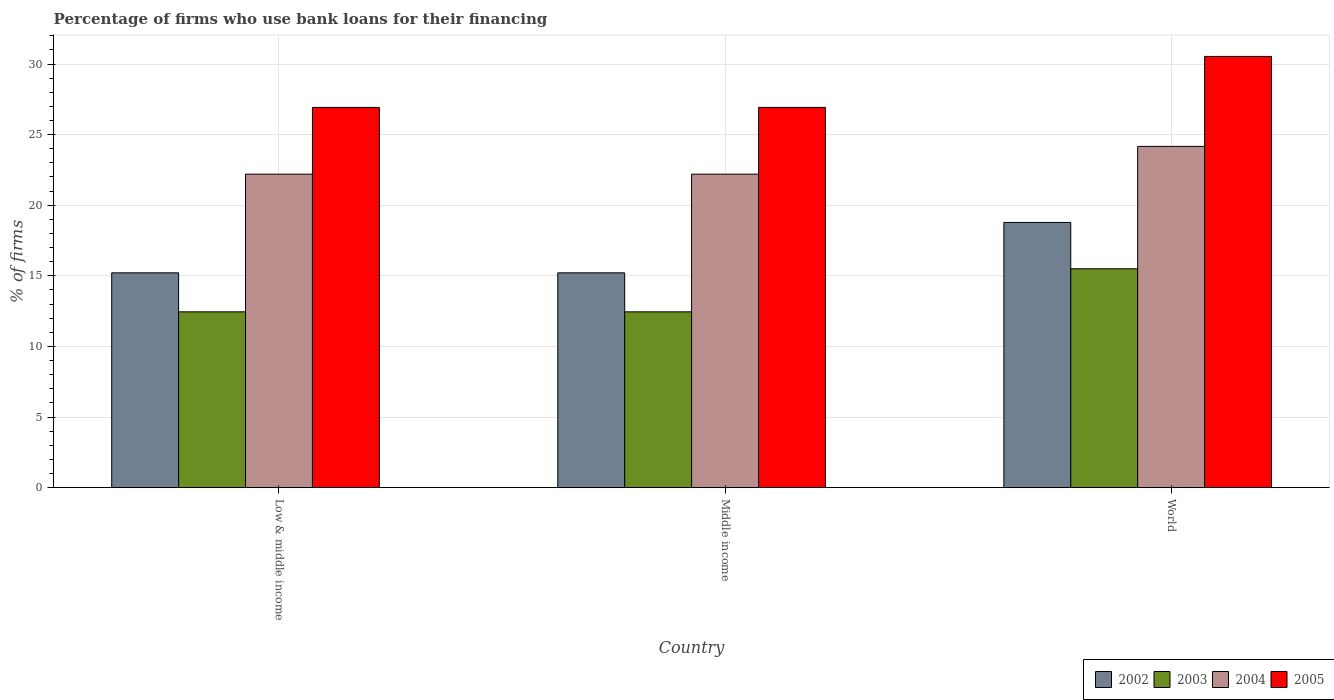Are the number of bars per tick equal to the number of legend labels?
Make the answer very short. Yes. How many bars are there on the 2nd tick from the left?
Your response must be concise. 4. How many bars are there on the 2nd tick from the right?
Provide a short and direct response. 4. What is the label of the 3rd group of bars from the left?
Ensure brevity in your answer.  World. What is the percentage of firms who use bank loans for their financing in 2005 in World?
Offer a very short reply. 30.54. Across all countries, what is the minimum percentage of firms who use bank loans for their financing in 2003?
Your response must be concise. 12.45. In which country was the percentage of firms who use bank loans for their financing in 2002 maximum?
Your answer should be very brief. World. What is the total percentage of firms who use bank loans for their financing in 2003 in the graph?
Provide a succinct answer. 40.4. What is the difference between the percentage of firms who use bank loans for their financing in 2004 in Low & middle income and that in World?
Your answer should be very brief. -1.97. What is the difference between the percentage of firms who use bank loans for their financing in 2003 in Middle income and the percentage of firms who use bank loans for their financing in 2005 in World?
Provide a short and direct response. -18.09. What is the average percentage of firms who use bank loans for their financing in 2003 per country?
Give a very brief answer. 13.47. What is the difference between the percentage of firms who use bank loans for their financing of/in 2004 and percentage of firms who use bank loans for their financing of/in 2005 in Low & middle income?
Keep it short and to the point. -4.73. In how many countries, is the percentage of firms who use bank loans for their financing in 2005 greater than 31 %?
Give a very brief answer. 0. What is the ratio of the percentage of firms who use bank loans for their financing in 2005 in Low & middle income to that in Middle income?
Give a very brief answer. 1. What is the difference between the highest and the second highest percentage of firms who use bank loans for their financing in 2003?
Your answer should be compact. -3.05. What is the difference between the highest and the lowest percentage of firms who use bank loans for their financing in 2003?
Your answer should be very brief. 3.05. In how many countries, is the percentage of firms who use bank loans for their financing in 2002 greater than the average percentage of firms who use bank loans for their financing in 2002 taken over all countries?
Offer a very short reply. 1. Is the sum of the percentage of firms who use bank loans for their financing in 2005 in Low & middle income and Middle income greater than the maximum percentage of firms who use bank loans for their financing in 2003 across all countries?
Offer a terse response. Yes. Is it the case that in every country, the sum of the percentage of firms who use bank loans for their financing in 2005 and percentage of firms who use bank loans for their financing in 2002 is greater than the sum of percentage of firms who use bank loans for their financing in 2003 and percentage of firms who use bank loans for their financing in 2004?
Offer a very short reply. No. What does the 3rd bar from the right in World represents?
Provide a succinct answer. 2003. Is it the case that in every country, the sum of the percentage of firms who use bank loans for their financing in 2002 and percentage of firms who use bank loans for their financing in 2003 is greater than the percentage of firms who use bank loans for their financing in 2005?
Offer a terse response. Yes. How many countries are there in the graph?
Ensure brevity in your answer.  3. What is the difference between two consecutive major ticks on the Y-axis?
Ensure brevity in your answer.  5. Does the graph contain any zero values?
Keep it short and to the point. No. Does the graph contain grids?
Offer a terse response. Yes. What is the title of the graph?
Offer a terse response. Percentage of firms who use bank loans for their financing. What is the label or title of the X-axis?
Ensure brevity in your answer.  Country. What is the label or title of the Y-axis?
Your response must be concise. % of firms. What is the % of firms of 2002 in Low & middle income?
Keep it short and to the point. 15.21. What is the % of firms of 2003 in Low & middle income?
Keep it short and to the point. 12.45. What is the % of firms of 2004 in Low & middle income?
Offer a very short reply. 22.2. What is the % of firms in 2005 in Low & middle income?
Make the answer very short. 26.93. What is the % of firms of 2002 in Middle income?
Keep it short and to the point. 15.21. What is the % of firms in 2003 in Middle income?
Ensure brevity in your answer.  12.45. What is the % of firms in 2005 in Middle income?
Your response must be concise. 26.93. What is the % of firms of 2002 in World?
Provide a short and direct response. 18.78. What is the % of firms of 2003 in World?
Keep it short and to the point. 15.5. What is the % of firms in 2004 in World?
Keep it short and to the point. 24.17. What is the % of firms of 2005 in World?
Keep it short and to the point. 30.54. Across all countries, what is the maximum % of firms of 2002?
Your answer should be compact. 18.78. Across all countries, what is the maximum % of firms of 2004?
Give a very brief answer. 24.17. Across all countries, what is the maximum % of firms in 2005?
Make the answer very short. 30.54. Across all countries, what is the minimum % of firms of 2002?
Ensure brevity in your answer.  15.21. Across all countries, what is the minimum % of firms of 2003?
Offer a terse response. 12.45. Across all countries, what is the minimum % of firms in 2005?
Provide a succinct answer. 26.93. What is the total % of firms in 2002 in the graph?
Your response must be concise. 49.21. What is the total % of firms of 2003 in the graph?
Give a very brief answer. 40.4. What is the total % of firms in 2004 in the graph?
Ensure brevity in your answer.  68.57. What is the total % of firms in 2005 in the graph?
Provide a succinct answer. 84.39. What is the difference between the % of firms in 2002 in Low & middle income and that in Middle income?
Offer a very short reply. 0. What is the difference between the % of firms in 2003 in Low & middle income and that in Middle income?
Your answer should be compact. 0. What is the difference between the % of firms in 2004 in Low & middle income and that in Middle income?
Your answer should be compact. 0. What is the difference between the % of firms of 2002 in Low & middle income and that in World?
Your answer should be compact. -3.57. What is the difference between the % of firms of 2003 in Low & middle income and that in World?
Your answer should be compact. -3.05. What is the difference between the % of firms of 2004 in Low & middle income and that in World?
Your answer should be compact. -1.97. What is the difference between the % of firms in 2005 in Low & middle income and that in World?
Make the answer very short. -3.61. What is the difference between the % of firms in 2002 in Middle income and that in World?
Make the answer very short. -3.57. What is the difference between the % of firms of 2003 in Middle income and that in World?
Offer a terse response. -3.05. What is the difference between the % of firms in 2004 in Middle income and that in World?
Your answer should be very brief. -1.97. What is the difference between the % of firms in 2005 in Middle income and that in World?
Give a very brief answer. -3.61. What is the difference between the % of firms of 2002 in Low & middle income and the % of firms of 2003 in Middle income?
Keep it short and to the point. 2.76. What is the difference between the % of firms of 2002 in Low & middle income and the % of firms of 2004 in Middle income?
Give a very brief answer. -6.99. What is the difference between the % of firms of 2002 in Low & middle income and the % of firms of 2005 in Middle income?
Your answer should be compact. -11.72. What is the difference between the % of firms in 2003 in Low & middle income and the % of firms in 2004 in Middle income?
Keep it short and to the point. -9.75. What is the difference between the % of firms of 2003 in Low & middle income and the % of firms of 2005 in Middle income?
Offer a terse response. -14.48. What is the difference between the % of firms of 2004 in Low & middle income and the % of firms of 2005 in Middle income?
Offer a very short reply. -4.73. What is the difference between the % of firms in 2002 in Low & middle income and the % of firms in 2003 in World?
Your answer should be very brief. -0.29. What is the difference between the % of firms of 2002 in Low & middle income and the % of firms of 2004 in World?
Your answer should be very brief. -8.95. What is the difference between the % of firms in 2002 in Low & middle income and the % of firms in 2005 in World?
Your answer should be very brief. -15.33. What is the difference between the % of firms of 2003 in Low & middle income and the % of firms of 2004 in World?
Your response must be concise. -11.72. What is the difference between the % of firms of 2003 in Low & middle income and the % of firms of 2005 in World?
Make the answer very short. -18.09. What is the difference between the % of firms in 2004 in Low & middle income and the % of firms in 2005 in World?
Your answer should be very brief. -8.34. What is the difference between the % of firms of 2002 in Middle income and the % of firms of 2003 in World?
Provide a short and direct response. -0.29. What is the difference between the % of firms in 2002 in Middle income and the % of firms in 2004 in World?
Make the answer very short. -8.95. What is the difference between the % of firms of 2002 in Middle income and the % of firms of 2005 in World?
Provide a succinct answer. -15.33. What is the difference between the % of firms in 2003 in Middle income and the % of firms in 2004 in World?
Give a very brief answer. -11.72. What is the difference between the % of firms of 2003 in Middle income and the % of firms of 2005 in World?
Offer a terse response. -18.09. What is the difference between the % of firms in 2004 in Middle income and the % of firms in 2005 in World?
Your answer should be compact. -8.34. What is the average % of firms of 2002 per country?
Ensure brevity in your answer.  16.4. What is the average % of firms of 2003 per country?
Provide a short and direct response. 13.47. What is the average % of firms of 2004 per country?
Make the answer very short. 22.86. What is the average % of firms in 2005 per country?
Offer a very short reply. 28.13. What is the difference between the % of firms of 2002 and % of firms of 2003 in Low & middle income?
Your answer should be compact. 2.76. What is the difference between the % of firms of 2002 and % of firms of 2004 in Low & middle income?
Ensure brevity in your answer.  -6.99. What is the difference between the % of firms of 2002 and % of firms of 2005 in Low & middle income?
Ensure brevity in your answer.  -11.72. What is the difference between the % of firms in 2003 and % of firms in 2004 in Low & middle income?
Give a very brief answer. -9.75. What is the difference between the % of firms of 2003 and % of firms of 2005 in Low & middle income?
Provide a succinct answer. -14.48. What is the difference between the % of firms of 2004 and % of firms of 2005 in Low & middle income?
Ensure brevity in your answer.  -4.73. What is the difference between the % of firms in 2002 and % of firms in 2003 in Middle income?
Ensure brevity in your answer.  2.76. What is the difference between the % of firms in 2002 and % of firms in 2004 in Middle income?
Make the answer very short. -6.99. What is the difference between the % of firms in 2002 and % of firms in 2005 in Middle income?
Keep it short and to the point. -11.72. What is the difference between the % of firms of 2003 and % of firms of 2004 in Middle income?
Ensure brevity in your answer.  -9.75. What is the difference between the % of firms of 2003 and % of firms of 2005 in Middle income?
Your answer should be compact. -14.48. What is the difference between the % of firms of 2004 and % of firms of 2005 in Middle income?
Ensure brevity in your answer.  -4.73. What is the difference between the % of firms of 2002 and % of firms of 2003 in World?
Make the answer very short. 3.28. What is the difference between the % of firms in 2002 and % of firms in 2004 in World?
Provide a succinct answer. -5.39. What is the difference between the % of firms in 2002 and % of firms in 2005 in World?
Keep it short and to the point. -11.76. What is the difference between the % of firms in 2003 and % of firms in 2004 in World?
Offer a terse response. -8.67. What is the difference between the % of firms of 2003 and % of firms of 2005 in World?
Keep it short and to the point. -15.04. What is the difference between the % of firms in 2004 and % of firms in 2005 in World?
Provide a succinct answer. -6.37. What is the ratio of the % of firms of 2003 in Low & middle income to that in Middle income?
Your response must be concise. 1. What is the ratio of the % of firms in 2004 in Low & middle income to that in Middle income?
Provide a short and direct response. 1. What is the ratio of the % of firms in 2005 in Low & middle income to that in Middle income?
Offer a very short reply. 1. What is the ratio of the % of firms in 2002 in Low & middle income to that in World?
Your answer should be compact. 0.81. What is the ratio of the % of firms in 2003 in Low & middle income to that in World?
Offer a very short reply. 0.8. What is the ratio of the % of firms of 2004 in Low & middle income to that in World?
Provide a succinct answer. 0.92. What is the ratio of the % of firms in 2005 in Low & middle income to that in World?
Keep it short and to the point. 0.88. What is the ratio of the % of firms of 2002 in Middle income to that in World?
Offer a very short reply. 0.81. What is the ratio of the % of firms in 2003 in Middle income to that in World?
Provide a succinct answer. 0.8. What is the ratio of the % of firms in 2004 in Middle income to that in World?
Provide a succinct answer. 0.92. What is the ratio of the % of firms of 2005 in Middle income to that in World?
Offer a very short reply. 0.88. What is the difference between the highest and the second highest % of firms of 2002?
Your answer should be very brief. 3.57. What is the difference between the highest and the second highest % of firms in 2003?
Your answer should be compact. 3.05. What is the difference between the highest and the second highest % of firms in 2004?
Make the answer very short. 1.97. What is the difference between the highest and the second highest % of firms in 2005?
Offer a terse response. 3.61. What is the difference between the highest and the lowest % of firms in 2002?
Offer a very short reply. 3.57. What is the difference between the highest and the lowest % of firms of 2003?
Ensure brevity in your answer.  3.05. What is the difference between the highest and the lowest % of firms of 2004?
Offer a terse response. 1.97. What is the difference between the highest and the lowest % of firms in 2005?
Give a very brief answer. 3.61. 